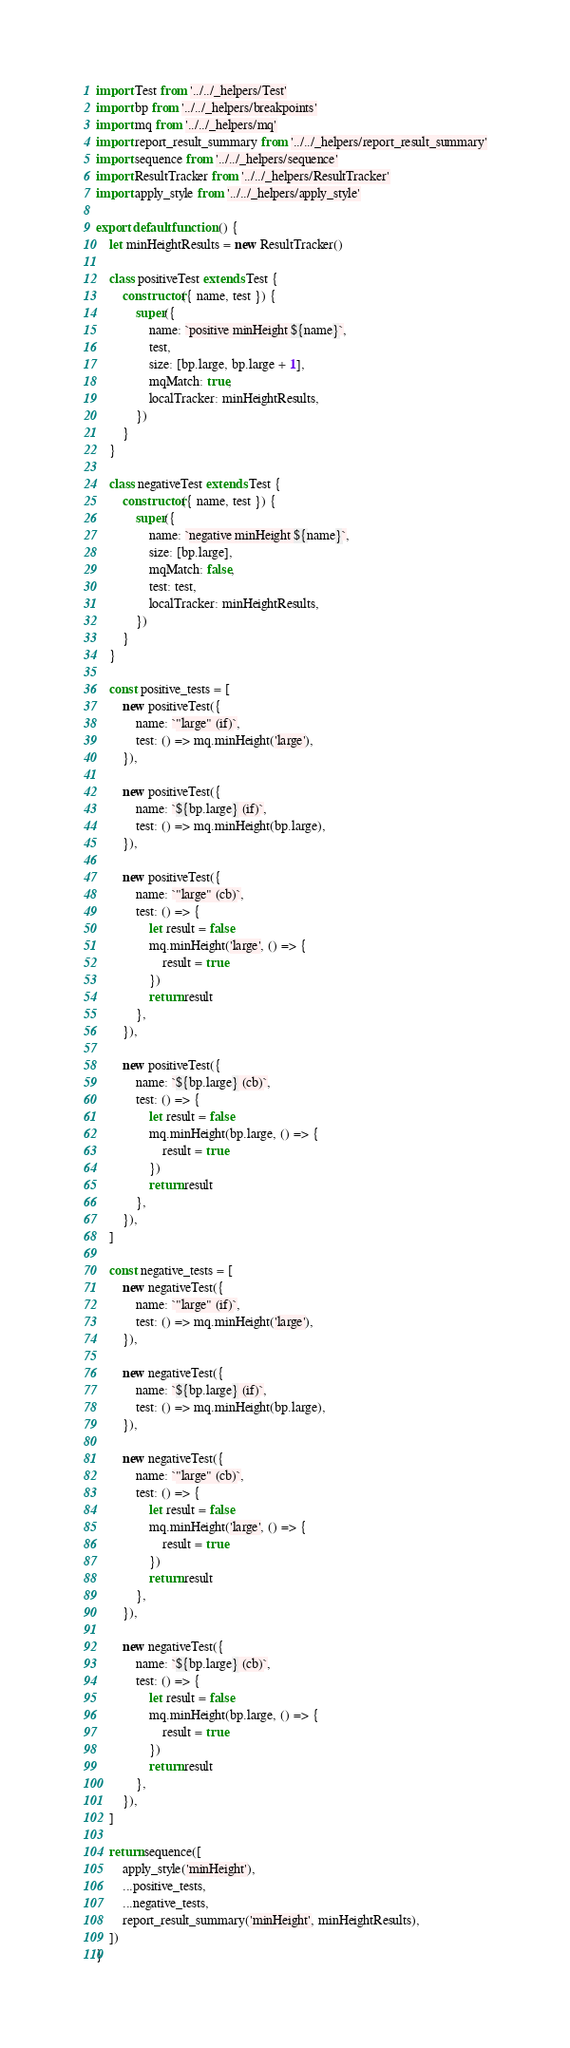<code> <loc_0><loc_0><loc_500><loc_500><_JavaScript_>import Test from '../../_helpers/Test'
import bp from '../../_helpers/breakpoints'
import mq from '../../_helpers/mq'
import report_result_summary from '../../_helpers/report_result_summary'
import sequence from '../../_helpers/sequence'
import ResultTracker from '../../_helpers/ResultTracker'
import apply_style from '../../_helpers/apply_style'

export default function () {
	let minHeightResults = new ResultTracker()

	class positiveTest extends Test {
		constructor({ name, test }) {
			super({
				name: `positive minHeight ${name}`,
				test,
				size: [bp.large, bp.large + 1],
				mqMatch: true,
				localTracker: minHeightResults,
			})
		}
	}

	class negativeTest extends Test {
		constructor({ name, test }) {
			super({
				name: `negative minHeight ${name}`,
				size: [bp.large],
				mqMatch: false,
				test: test,
				localTracker: minHeightResults,
			})
		}
	}

	const positive_tests = [
		new positiveTest({
			name: `"large" (if)`,
			test: () => mq.minHeight('large'),
		}),

		new positiveTest({
			name: `${bp.large} (if)`,
			test: () => mq.minHeight(bp.large),
		}),

		new positiveTest({
			name: `"large" (cb)`,
			test: () => {
				let result = false
				mq.minHeight('large', () => {
					result = true
				})
				return result
			},
		}),

		new positiveTest({
			name: `${bp.large} (cb)`,
			test: () => {
				let result = false
				mq.minHeight(bp.large, () => {
					result = true
				})
				return result
			},
		}),
	]

	const negative_tests = [
		new negativeTest({
			name: `"large" (if)`,
			test: () => mq.minHeight('large'),
		}),

		new negativeTest({
			name: `${bp.large} (if)`,
			test: () => mq.minHeight(bp.large),
		}),

		new negativeTest({
			name: `"large" (cb)`,
			test: () => {
				let result = false
				mq.minHeight('large', () => {
					result = true
				})
				return result
			},
		}),

		new negativeTest({
			name: `${bp.large} (cb)`,
			test: () => {
				let result = false
				mq.minHeight(bp.large, () => {
					result = true
				})
				return result
			},
		}),
	]

	return sequence([
		apply_style('minHeight'),
		...positive_tests,
		...negative_tests,
		report_result_summary('minHeight', minHeightResults),
	])
}
</code> 